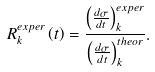Convert formula to latex. <formula><loc_0><loc_0><loc_500><loc_500>R _ { k } ^ { e x p e r } \left ( t \right ) = \frac { \left ( \frac { d \sigma } { d t } \right ) _ { k } ^ { e x p e r } } { \left ( \frac { d \sigma } { d t } \right ) _ { k } ^ { t h e o r } } .</formula> 